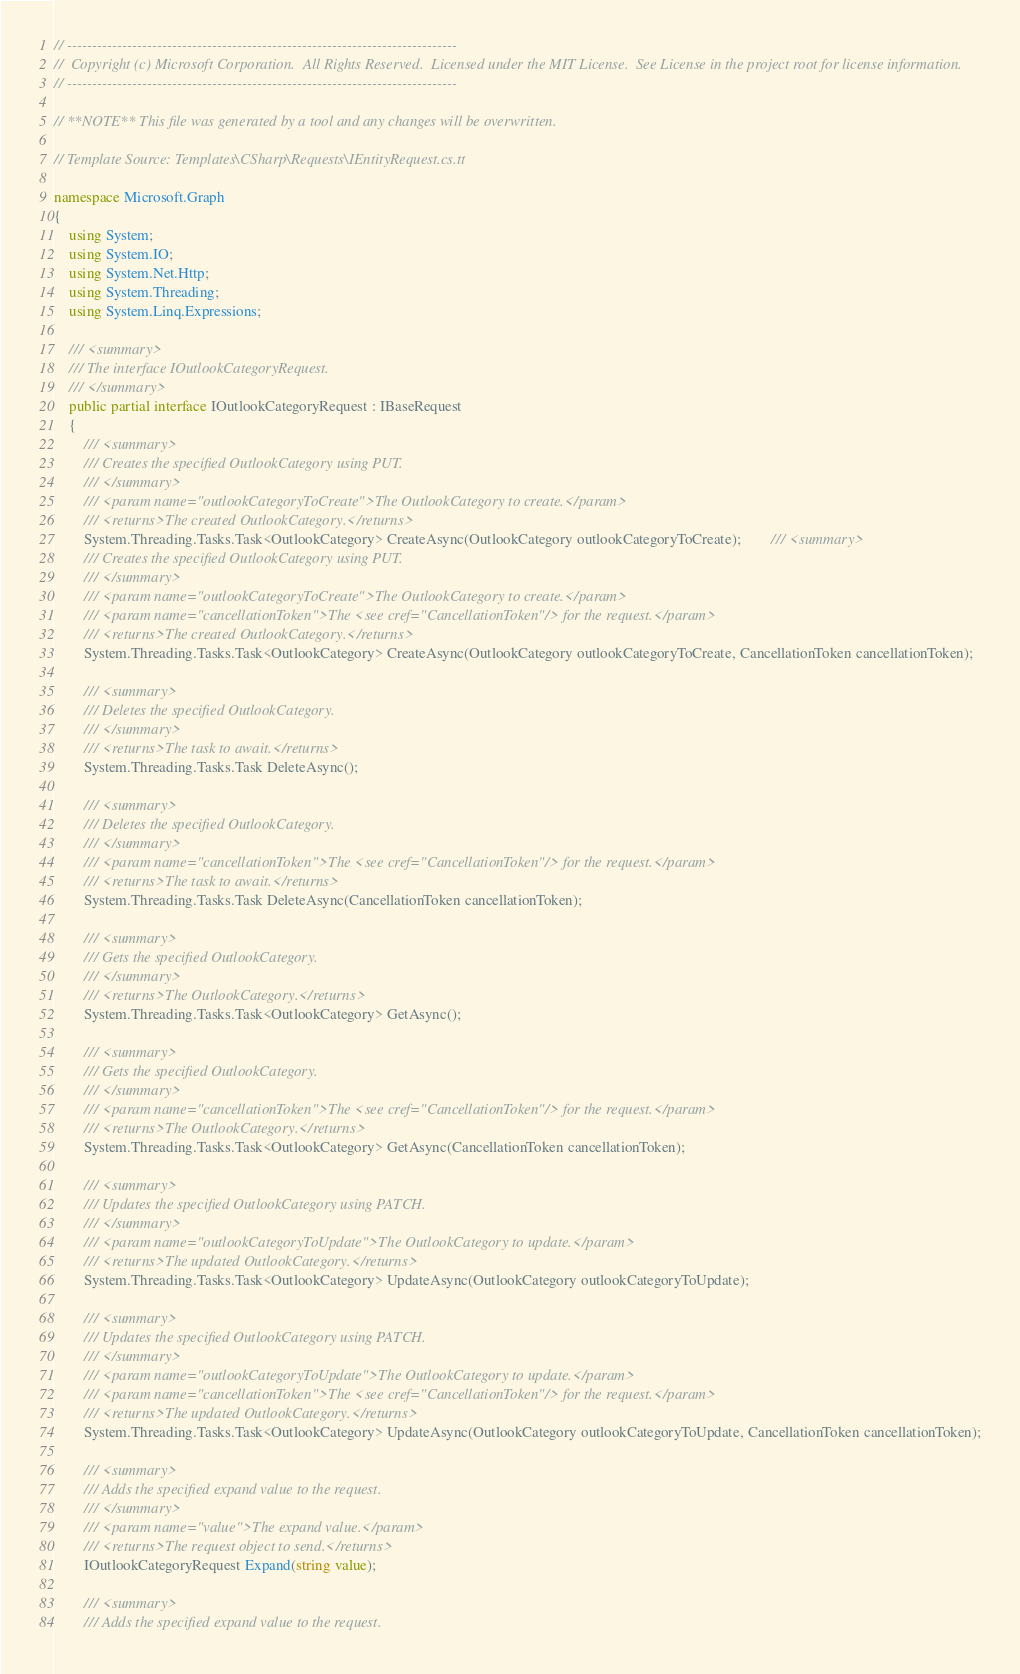<code> <loc_0><loc_0><loc_500><loc_500><_C#_>// ------------------------------------------------------------------------------
//  Copyright (c) Microsoft Corporation.  All Rights Reserved.  Licensed under the MIT License.  See License in the project root for license information.
// ------------------------------------------------------------------------------

// **NOTE** This file was generated by a tool and any changes will be overwritten.

// Template Source: Templates\CSharp\Requests\IEntityRequest.cs.tt

namespace Microsoft.Graph
{
    using System;
    using System.IO;
    using System.Net.Http;
    using System.Threading;
    using System.Linq.Expressions;

    /// <summary>
    /// The interface IOutlookCategoryRequest.
    /// </summary>
    public partial interface IOutlookCategoryRequest : IBaseRequest
    {
        /// <summary>
        /// Creates the specified OutlookCategory using PUT.
        /// </summary>
        /// <param name="outlookCategoryToCreate">The OutlookCategory to create.</param>
        /// <returns>The created OutlookCategory.</returns>
        System.Threading.Tasks.Task<OutlookCategory> CreateAsync(OutlookCategory outlookCategoryToCreate);        /// <summary>
        /// Creates the specified OutlookCategory using PUT.
        /// </summary>
        /// <param name="outlookCategoryToCreate">The OutlookCategory to create.</param>
        /// <param name="cancellationToken">The <see cref="CancellationToken"/> for the request.</param>
        /// <returns>The created OutlookCategory.</returns>
        System.Threading.Tasks.Task<OutlookCategory> CreateAsync(OutlookCategory outlookCategoryToCreate, CancellationToken cancellationToken);

        /// <summary>
        /// Deletes the specified OutlookCategory.
        /// </summary>
        /// <returns>The task to await.</returns>
        System.Threading.Tasks.Task DeleteAsync();

        /// <summary>
        /// Deletes the specified OutlookCategory.
        /// </summary>
        /// <param name="cancellationToken">The <see cref="CancellationToken"/> for the request.</param>
        /// <returns>The task to await.</returns>
        System.Threading.Tasks.Task DeleteAsync(CancellationToken cancellationToken);

        /// <summary>
        /// Gets the specified OutlookCategory.
        /// </summary>
        /// <returns>The OutlookCategory.</returns>
        System.Threading.Tasks.Task<OutlookCategory> GetAsync();

        /// <summary>
        /// Gets the specified OutlookCategory.
        /// </summary>
        /// <param name="cancellationToken">The <see cref="CancellationToken"/> for the request.</param>
        /// <returns>The OutlookCategory.</returns>
        System.Threading.Tasks.Task<OutlookCategory> GetAsync(CancellationToken cancellationToken);

        /// <summary>
        /// Updates the specified OutlookCategory using PATCH.
        /// </summary>
        /// <param name="outlookCategoryToUpdate">The OutlookCategory to update.</param>
        /// <returns>The updated OutlookCategory.</returns>
        System.Threading.Tasks.Task<OutlookCategory> UpdateAsync(OutlookCategory outlookCategoryToUpdate);

        /// <summary>
        /// Updates the specified OutlookCategory using PATCH.
        /// </summary>
        /// <param name="outlookCategoryToUpdate">The OutlookCategory to update.</param>
        /// <param name="cancellationToken">The <see cref="CancellationToken"/> for the request.</param>
        /// <returns>The updated OutlookCategory.</returns>
        System.Threading.Tasks.Task<OutlookCategory> UpdateAsync(OutlookCategory outlookCategoryToUpdate, CancellationToken cancellationToken);

        /// <summary>
        /// Adds the specified expand value to the request.
        /// </summary>
        /// <param name="value">The expand value.</param>
        /// <returns>The request object to send.</returns>
        IOutlookCategoryRequest Expand(string value);

        /// <summary>
        /// Adds the specified expand value to the request.</code> 